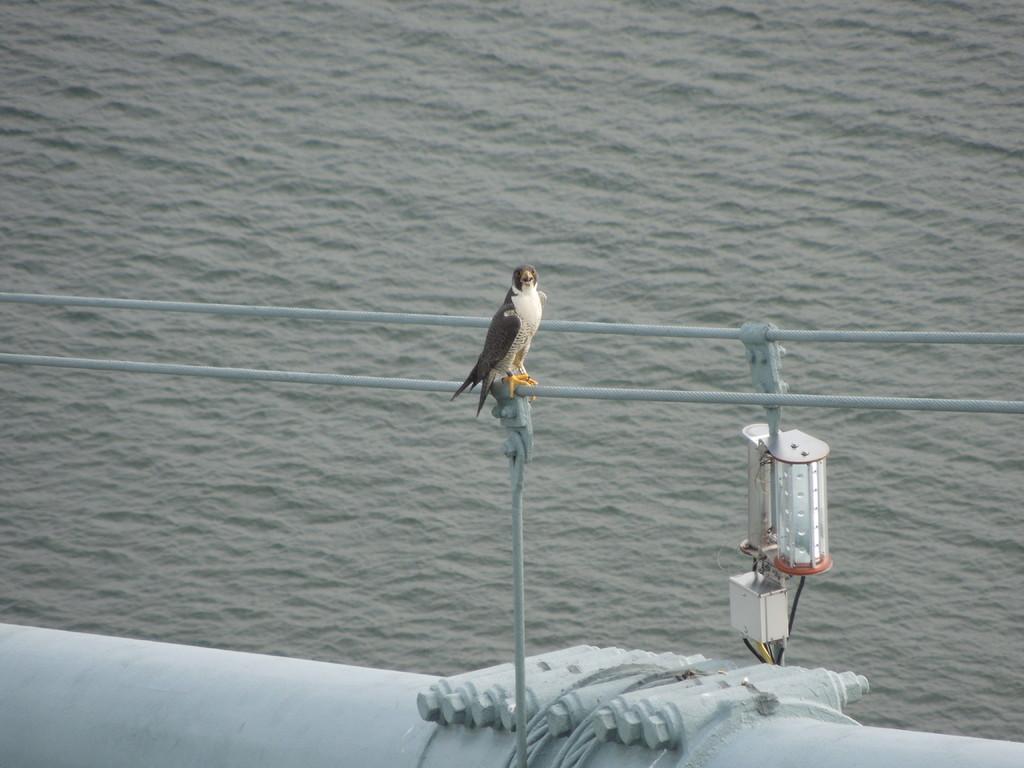Could you give a brief overview of what you see in this image? In this picture there is a bird standing on the rod. There is a light on the rod and at the bottom there is a metal pipe. At the back there is water. 